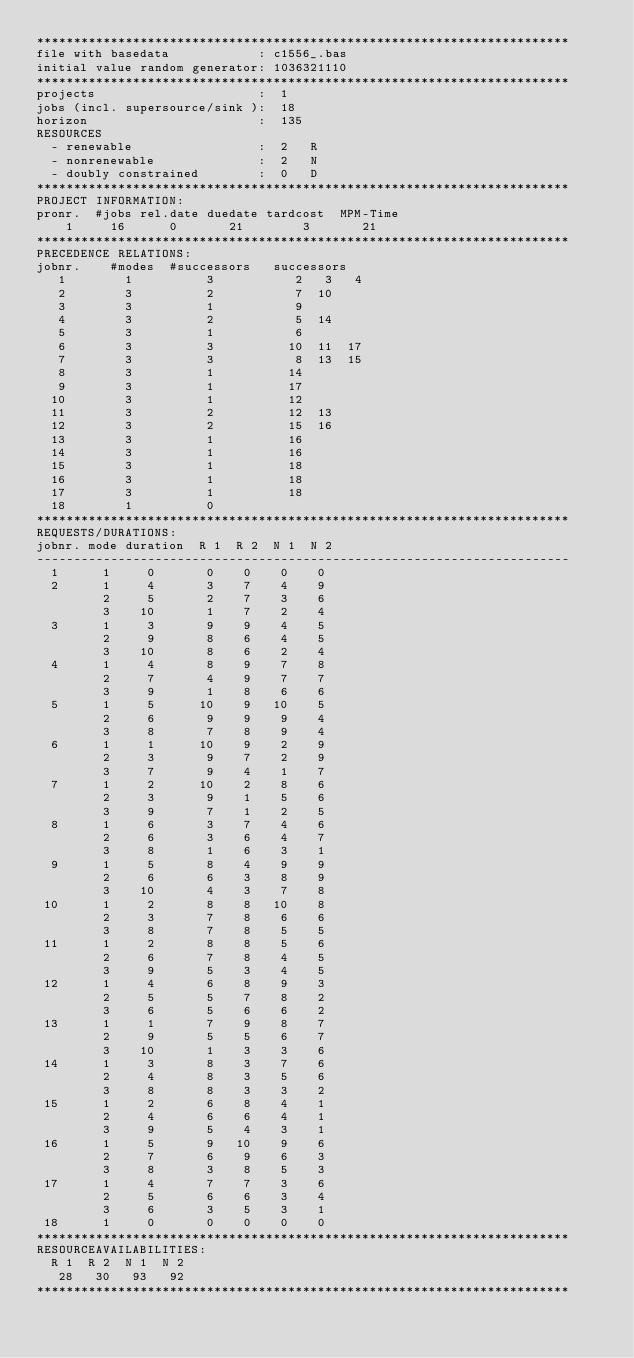Convert code to text. <code><loc_0><loc_0><loc_500><loc_500><_ObjectiveC_>************************************************************************
file with basedata            : c1556_.bas
initial value random generator: 1036321110
************************************************************************
projects                      :  1
jobs (incl. supersource/sink ):  18
horizon                       :  135
RESOURCES
  - renewable                 :  2   R
  - nonrenewable              :  2   N
  - doubly constrained        :  0   D
************************************************************************
PROJECT INFORMATION:
pronr.  #jobs rel.date duedate tardcost  MPM-Time
    1     16      0       21        3       21
************************************************************************
PRECEDENCE RELATIONS:
jobnr.    #modes  #successors   successors
   1        1          3           2   3   4
   2        3          2           7  10
   3        3          1           9
   4        3          2           5  14
   5        3          1           6
   6        3          3          10  11  17
   7        3          3           8  13  15
   8        3          1          14
   9        3          1          17
  10        3          1          12
  11        3          2          12  13
  12        3          2          15  16
  13        3          1          16
  14        3          1          16
  15        3          1          18
  16        3          1          18
  17        3          1          18
  18        1          0        
************************************************************************
REQUESTS/DURATIONS:
jobnr. mode duration  R 1  R 2  N 1  N 2
------------------------------------------------------------------------
  1      1     0       0    0    0    0
  2      1     4       3    7    4    9
         2     5       2    7    3    6
         3    10       1    7    2    4
  3      1     3       9    9    4    5
         2     9       8    6    4    5
         3    10       8    6    2    4
  4      1     4       8    9    7    8
         2     7       4    9    7    7
         3     9       1    8    6    6
  5      1     5      10    9   10    5
         2     6       9    9    9    4
         3     8       7    8    9    4
  6      1     1      10    9    2    9
         2     3       9    7    2    9
         3     7       9    4    1    7
  7      1     2      10    2    8    6
         2     3       9    1    5    6
         3     9       7    1    2    5
  8      1     6       3    7    4    6
         2     6       3    6    4    7
         3     8       1    6    3    1
  9      1     5       8    4    9    9
         2     6       6    3    8    9
         3    10       4    3    7    8
 10      1     2       8    8   10    8
         2     3       7    8    6    6
         3     8       7    8    5    5
 11      1     2       8    8    5    6
         2     6       7    8    4    5
         3     9       5    3    4    5
 12      1     4       6    8    9    3
         2     5       5    7    8    2
         3     6       5    6    6    2
 13      1     1       7    9    8    7
         2     9       5    5    6    7
         3    10       1    3    3    6
 14      1     3       8    3    7    6
         2     4       8    3    5    6
         3     8       8    3    3    2
 15      1     2       6    8    4    1
         2     4       6    6    4    1
         3     9       5    4    3    1
 16      1     5       9   10    9    6
         2     7       6    9    6    3
         3     8       3    8    5    3
 17      1     4       7    7    3    6
         2     5       6    6    3    4
         3     6       3    5    3    1
 18      1     0       0    0    0    0
************************************************************************
RESOURCEAVAILABILITIES:
  R 1  R 2  N 1  N 2
   28   30   93   92
************************************************************************
</code> 